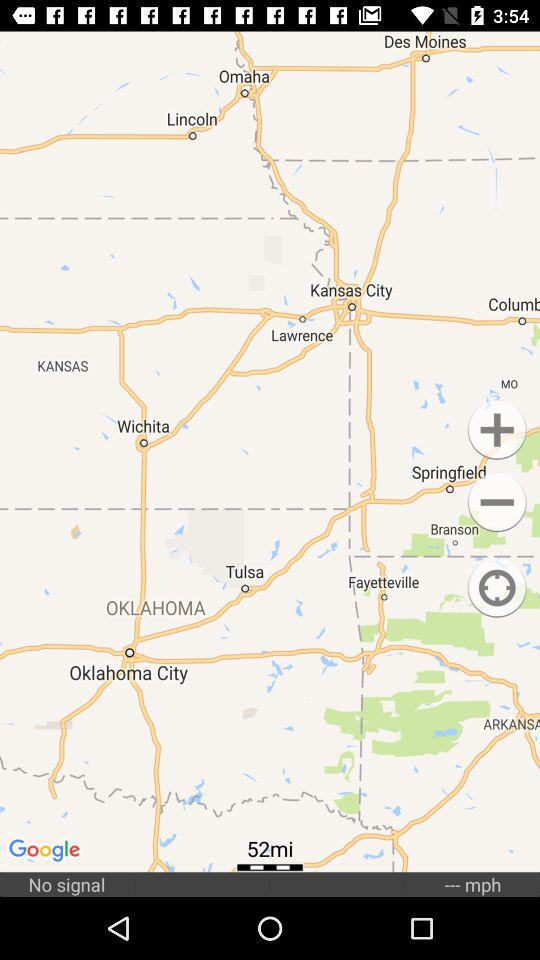How many miles away is the destination?
Answer the question using a single word or phrase. 52 